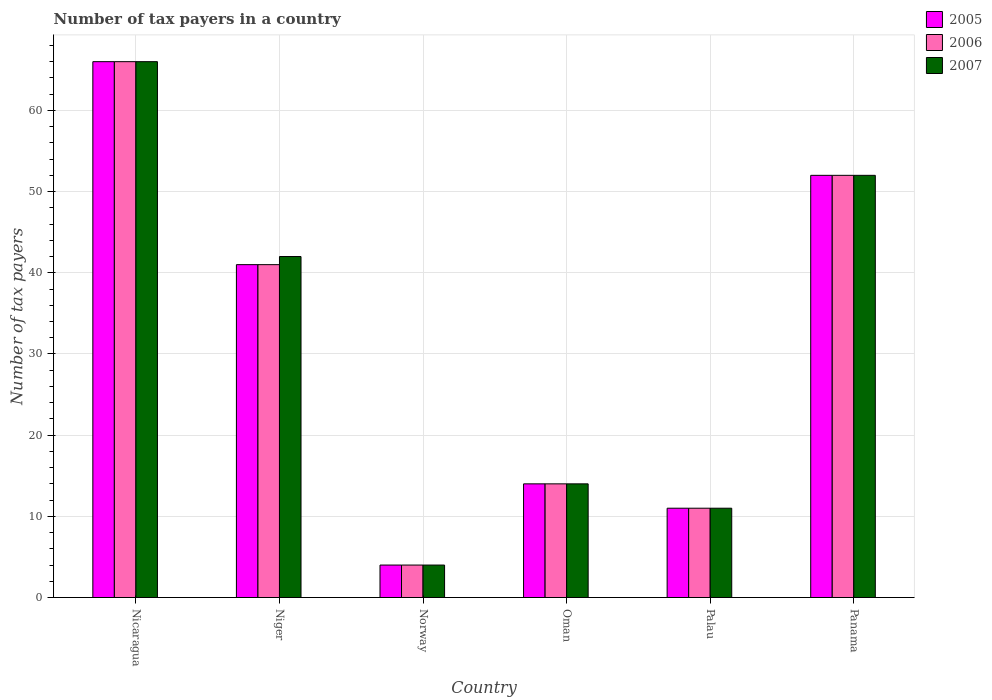How many different coloured bars are there?
Your response must be concise. 3. Are the number of bars per tick equal to the number of legend labels?
Offer a terse response. Yes. How many bars are there on the 5th tick from the left?
Provide a succinct answer. 3. What is the label of the 6th group of bars from the left?
Make the answer very short. Panama. In how many cases, is the number of bars for a given country not equal to the number of legend labels?
Keep it short and to the point. 0. Across all countries, what is the minimum number of tax payers in in 2007?
Offer a very short reply. 4. In which country was the number of tax payers in in 2006 maximum?
Your answer should be very brief. Nicaragua. What is the total number of tax payers in in 2007 in the graph?
Offer a terse response. 189. What is the difference between the number of tax payers in in 2006 in Nicaragua and that in Norway?
Make the answer very short. 62. What is the difference between the number of tax payers in in 2005 in Norway and the number of tax payers in in 2007 in Panama?
Ensure brevity in your answer.  -48. What is the average number of tax payers in in 2007 per country?
Give a very brief answer. 31.5. In how many countries, is the number of tax payers in in 2005 greater than 60?
Offer a very short reply. 1. What is the ratio of the number of tax payers in in 2005 in Norway to that in Panama?
Your response must be concise. 0.08. Is the number of tax payers in in 2007 in Oman less than that in Panama?
Ensure brevity in your answer.  Yes. Is the difference between the number of tax payers in in 2005 in Niger and Panama greater than the difference between the number of tax payers in in 2006 in Niger and Panama?
Your answer should be compact. No. What is the difference between the highest and the second highest number of tax payers in in 2006?
Provide a short and direct response. -25. In how many countries, is the number of tax payers in in 2006 greater than the average number of tax payers in in 2006 taken over all countries?
Offer a terse response. 3. What does the 2nd bar from the left in Nicaragua represents?
Give a very brief answer. 2006. Is it the case that in every country, the sum of the number of tax payers in in 2005 and number of tax payers in in 2007 is greater than the number of tax payers in in 2006?
Your answer should be compact. Yes. How many bars are there?
Provide a succinct answer. 18. Are all the bars in the graph horizontal?
Offer a terse response. No. How many countries are there in the graph?
Keep it short and to the point. 6. Does the graph contain grids?
Your answer should be compact. Yes. Where does the legend appear in the graph?
Your response must be concise. Top right. How many legend labels are there?
Your response must be concise. 3. What is the title of the graph?
Keep it short and to the point. Number of tax payers in a country. What is the label or title of the X-axis?
Ensure brevity in your answer.  Country. What is the label or title of the Y-axis?
Your answer should be very brief. Number of tax payers. What is the Number of tax payers of 2005 in Nicaragua?
Keep it short and to the point. 66. What is the Number of tax payers of 2007 in Nicaragua?
Provide a short and direct response. 66. What is the Number of tax payers of 2006 in Niger?
Ensure brevity in your answer.  41. What is the Number of tax payers in 2007 in Niger?
Offer a very short reply. 42. What is the Number of tax payers in 2005 in Norway?
Provide a short and direct response. 4. What is the Number of tax payers of 2006 in Norway?
Offer a very short reply. 4. What is the Number of tax payers in 2005 in Oman?
Ensure brevity in your answer.  14. What is the Number of tax payers in 2006 in Palau?
Keep it short and to the point. 11. What is the Number of tax payers in 2005 in Panama?
Offer a very short reply. 52. What is the Number of tax payers in 2006 in Panama?
Make the answer very short. 52. What is the Number of tax payers in 2007 in Panama?
Offer a terse response. 52. Across all countries, what is the maximum Number of tax payers of 2005?
Your response must be concise. 66. Across all countries, what is the maximum Number of tax payers of 2006?
Your answer should be compact. 66. Across all countries, what is the maximum Number of tax payers of 2007?
Your answer should be compact. 66. Across all countries, what is the minimum Number of tax payers in 2006?
Your answer should be very brief. 4. What is the total Number of tax payers of 2005 in the graph?
Keep it short and to the point. 188. What is the total Number of tax payers in 2006 in the graph?
Your response must be concise. 188. What is the total Number of tax payers in 2007 in the graph?
Provide a short and direct response. 189. What is the difference between the Number of tax payers in 2005 in Nicaragua and that in Niger?
Provide a short and direct response. 25. What is the difference between the Number of tax payers of 2006 in Nicaragua and that in Niger?
Your response must be concise. 25. What is the difference between the Number of tax payers in 2007 in Nicaragua and that in Niger?
Provide a succinct answer. 24. What is the difference between the Number of tax payers in 2006 in Nicaragua and that in Norway?
Your answer should be compact. 62. What is the difference between the Number of tax payers of 2006 in Nicaragua and that in Palau?
Your answer should be very brief. 55. What is the difference between the Number of tax payers in 2007 in Nicaragua and that in Palau?
Ensure brevity in your answer.  55. What is the difference between the Number of tax payers of 2006 in Niger and that in Norway?
Offer a terse response. 37. What is the difference between the Number of tax payers of 2007 in Niger and that in Norway?
Provide a succinct answer. 38. What is the difference between the Number of tax payers in 2005 in Niger and that in Oman?
Give a very brief answer. 27. What is the difference between the Number of tax payers in 2007 in Niger and that in Oman?
Keep it short and to the point. 28. What is the difference between the Number of tax payers of 2005 in Niger and that in Palau?
Your answer should be compact. 30. What is the difference between the Number of tax payers in 2007 in Niger and that in Palau?
Provide a succinct answer. 31. What is the difference between the Number of tax payers in 2005 in Norway and that in Oman?
Offer a terse response. -10. What is the difference between the Number of tax payers of 2006 in Norway and that in Oman?
Keep it short and to the point. -10. What is the difference between the Number of tax payers in 2006 in Norway and that in Palau?
Provide a succinct answer. -7. What is the difference between the Number of tax payers of 2005 in Norway and that in Panama?
Your response must be concise. -48. What is the difference between the Number of tax payers in 2006 in Norway and that in Panama?
Provide a short and direct response. -48. What is the difference between the Number of tax payers of 2007 in Norway and that in Panama?
Provide a succinct answer. -48. What is the difference between the Number of tax payers of 2005 in Oman and that in Palau?
Keep it short and to the point. 3. What is the difference between the Number of tax payers in 2006 in Oman and that in Palau?
Your answer should be very brief. 3. What is the difference between the Number of tax payers in 2007 in Oman and that in Palau?
Provide a short and direct response. 3. What is the difference between the Number of tax payers of 2005 in Oman and that in Panama?
Your answer should be compact. -38. What is the difference between the Number of tax payers of 2006 in Oman and that in Panama?
Provide a succinct answer. -38. What is the difference between the Number of tax payers of 2007 in Oman and that in Panama?
Keep it short and to the point. -38. What is the difference between the Number of tax payers in 2005 in Palau and that in Panama?
Provide a succinct answer. -41. What is the difference between the Number of tax payers in 2006 in Palau and that in Panama?
Make the answer very short. -41. What is the difference between the Number of tax payers in 2007 in Palau and that in Panama?
Your answer should be compact. -41. What is the difference between the Number of tax payers in 2005 in Nicaragua and the Number of tax payers in 2006 in Niger?
Your answer should be compact. 25. What is the difference between the Number of tax payers in 2005 in Nicaragua and the Number of tax payers in 2007 in Niger?
Provide a succinct answer. 24. What is the difference between the Number of tax payers of 2005 in Nicaragua and the Number of tax payers of 2007 in Norway?
Make the answer very short. 62. What is the difference between the Number of tax payers of 2006 in Nicaragua and the Number of tax payers of 2007 in Norway?
Provide a succinct answer. 62. What is the difference between the Number of tax payers in 2005 in Nicaragua and the Number of tax payers in 2007 in Oman?
Make the answer very short. 52. What is the difference between the Number of tax payers of 2005 in Nicaragua and the Number of tax payers of 2006 in Palau?
Ensure brevity in your answer.  55. What is the difference between the Number of tax payers of 2006 in Nicaragua and the Number of tax payers of 2007 in Palau?
Make the answer very short. 55. What is the difference between the Number of tax payers in 2005 in Nicaragua and the Number of tax payers in 2006 in Panama?
Keep it short and to the point. 14. What is the difference between the Number of tax payers of 2005 in Niger and the Number of tax payers of 2007 in Norway?
Your answer should be compact. 37. What is the difference between the Number of tax payers in 2005 in Niger and the Number of tax payers in 2006 in Palau?
Provide a short and direct response. 30. What is the difference between the Number of tax payers in 2005 in Niger and the Number of tax payers in 2007 in Panama?
Provide a succinct answer. -11. What is the difference between the Number of tax payers of 2006 in Niger and the Number of tax payers of 2007 in Panama?
Make the answer very short. -11. What is the difference between the Number of tax payers in 2005 in Norway and the Number of tax payers in 2007 in Oman?
Give a very brief answer. -10. What is the difference between the Number of tax payers in 2006 in Norway and the Number of tax payers in 2007 in Palau?
Keep it short and to the point. -7. What is the difference between the Number of tax payers in 2005 in Norway and the Number of tax payers in 2006 in Panama?
Offer a very short reply. -48. What is the difference between the Number of tax payers in 2005 in Norway and the Number of tax payers in 2007 in Panama?
Offer a terse response. -48. What is the difference between the Number of tax payers of 2006 in Norway and the Number of tax payers of 2007 in Panama?
Your answer should be compact. -48. What is the difference between the Number of tax payers of 2005 in Oman and the Number of tax payers of 2006 in Palau?
Keep it short and to the point. 3. What is the difference between the Number of tax payers in 2006 in Oman and the Number of tax payers in 2007 in Palau?
Your answer should be very brief. 3. What is the difference between the Number of tax payers of 2005 in Oman and the Number of tax payers of 2006 in Panama?
Keep it short and to the point. -38. What is the difference between the Number of tax payers in 2005 in Oman and the Number of tax payers in 2007 in Panama?
Keep it short and to the point. -38. What is the difference between the Number of tax payers of 2006 in Oman and the Number of tax payers of 2007 in Panama?
Offer a very short reply. -38. What is the difference between the Number of tax payers of 2005 in Palau and the Number of tax payers of 2006 in Panama?
Give a very brief answer. -41. What is the difference between the Number of tax payers in 2005 in Palau and the Number of tax payers in 2007 in Panama?
Your answer should be very brief. -41. What is the difference between the Number of tax payers in 2006 in Palau and the Number of tax payers in 2007 in Panama?
Make the answer very short. -41. What is the average Number of tax payers in 2005 per country?
Your answer should be compact. 31.33. What is the average Number of tax payers in 2006 per country?
Provide a succinct answer. 31.33. What is the average Number of tax payers of 2007 per country?
Keep it short and to the point. 31.5. What is the difference between the Number of tax payers of 2005 and Number of tax payers of 2006 in Nicaragua?
Your response must be concise. 0. What is the difference between the Number of tax payers in 2005 and Number of tax payers in 2007 in Nicaragua?
Your response must be concise. 0. What is the difference between the Number of tax payers of 2005 and Number of tax payers of 2007 in Niger?
Keep it short and to the point. -1. What is the difference between the Number of tax payers in 2006 and Number of tax payers in 2007 in Niger?
Your answer should be compact. -1. What is the difference between the Number of tax payers of 2005 and Number of tax payers of 2006 in Norway?
Ensure brevity in your answer.  0. What is the difference between the Number of tax payers in 2005 and Number of tax payers in 2007 in Norway?
Your answer should be compact. 0. What is the difference between the Number of tax payers of 2005 and Number of tax payers of 2006 in Oman?
Offer a terse response. 0. What is the difference between the Number of tax payers of 2005 and Number of tax payers of 2007 in Palau?
Make the answer very short. 0. What is the ratio of the Number of tax payers in 2005 in Nicaragua to that in Niger?
Provide a short and direct response. 1.61. What is the ratio of the Number of tax payers in 2006 in Nicaragua to that in Niger?
Keep it short and to the point. 1.61. What is the ratio of the Number of tax payers of 2007 in Nicaragua to that in Niger?
Your answer should be compact. 1.57. What is the ratio of the Number of tax payers in 2005 in Nicaragua to that in Oman?
Ensure brevity in your answer.  4.71. What is the ratio of the Number of tax payers of 2006 in Nicaragua to that in Oman?
Ensure brevity in your answer.  4.71. What is the ratio of the Number of tax payers of 2007 in Nicaragua to that in Oman?
Provide a succinct answer. 4.71. What is the ratio of the Number of tax payers in 2007 in Nicaragua to that in Palau?
Offer a very short reply. 6. What is the ratio of the Number of tax payers of 2005 in Nicaragua to that in Panama?
Offer a very short reply. 1.27. What is the ratio of the Number of tax payers of 2006 in Nicaragua to that in Panama?
Keep it short and to the point. 1.27. What is the ratio of the Number of tax payers of 2007 in Nicaragua to that in Panama?
Your response must be concise. 1.27. What is the ratio of the Number of tax payers of 2005 in Niger to that in Norway?
Your response must be concise. 10.25. What is the ratio of the Number of tax payers of 2006 in Niger to that in Norway?
Your answer should be very brief. 10.25. What is the ratio of the Number of tax payers of 2005 in Niger to that in Oman?
Your response must be concise. 2.93. What is the ratio of the Number of tax payers of 2006 in Niger to that in Oman?
Your answer should be very brief. 2.93. What is the ratio of the Number of tax payers in 2005 in Niger to that in Palau?
Offer a terse response. 3.73. What is the ratio of the Number of tax payers of 2006 in Niger to that in Palau?
Offer a terse response. 3.73. What is the ratio of the Number of tax payers of 2007 in Niger to that in Palau?
Provide a succinct answer. 3.82. What is the ratio of the Number of tax payers in 2005 in Niger to that in Panama?
Keep it short and to the point. 0.79. What is the ratio of the Number of tax payers in 2006 in Niger to that in Panama?
Provide a succinct answer. 0.79. What is the ratio of the Number of tax payers of 2007 in Niger to that in Panama?
Keep it short and to the point. 0.81. What is the ratio of the Number of tax payers in 2005 in Norway to that in Oman?
Provide a short and direct response. 0.29. What is the ratio of the Number of tax payers of 2006 in Norway to that in Oman?
Keep it short and to the point. 0.29. What is the ratio of the Number of tax payers of 2007 in Norway to that in Oman?
Your answer should be compact. 0.29. What is the ratio of the Number of tax payers in 2005 in Norway to that in Palau?
Your response must be concise. 0.36. What is the ratio of the Number of tax payers of 2006 in Norway to that in Palau?
Offer a terse response. 0.36. What is the ratio of the Number of tax payers of 2007 in Norway to that in Palau?
Your response must be concise. 0.36. What is the ratio of the Number of tax payers in 2005 in Norway to that in Panama?
Ensure brevity in your answer.  0.08. What is the ratio of the Number of tax payers of 2006 in Norway to that in Panama?
Keep it short and to the point. 0.08. What is the ratio of the Number of tax payers in 2007 in Norway to that in Panama?
Offer a very short reply. 0.08. What is the ratio of the Number of tax payers in 2005 in Oman to that in Palau?
Give a very brief answer. 1.27. What is the ratio of the Number of tax payers of 2006 in Oman to that in Palau?
Provide a short and direct response. 1.27. What is the ratio of the Number of tax payers in 2007 in Oman to that in Palau?
Your answer should be very brief. 1.27. What is the ratio of the Number of tax payers in 2005 in Oman to that in Panama?
Provide a succinct answer. 0.27. What is the ratio of the Number of tax payers in 2006 in Oman to that in Panama?
Your answer should be very brief. 0.27. What is the ratio of the Number of tax payers in 2007 in Oman to that in Panama?
Ensure brevity in your answer.  0.27. What is the ratio of the Number of tax payers in 2005 in Palau to that in Panama?
Provide a succinct answer. 0.21. What is the ratio of the Number of tax payers of 2006 in Palau to that in Panama?
Make the answer very short. 0.21. What is the ratio of the Number of tax payers of 2007 in Palau to that in Panama?
Your answer should be compact. 0.21. What is the difference between the highest and the second highest Number of tax payers in 2006?
Give a very brief answer. 14. What is the difference between the highest and the lowest Number of tax payers in 2005?
Provide a succinct answer. 62. What is the difference between the highest and the lowest Number of tax payers in 2006?
Your answer should be compact. 62. What is the difference between the highest and the lowest Number of tax payers of 2007?
Provide a succinct answer. 62. 